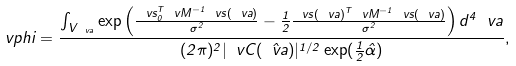Convert formula to latex. <formula><loc_0><loc_0><loc_500><loc_500>\ v p h i = \frac { \int _ { V _ { \ v a } } \exp \left ( \frac { \ v s ^ { T } _ { 0 } \ v M ^ { - 1 } \ v s ( \ v a ) } { \sigma ^ { 2 } } - \frac { 1 } { 2 } \frac { \ v s ( \ v a ) ^ { T } \ v M ^ { - 1 } \ v s ( \ v a ) } { \sigma ^ { 2 } } \right ) d ^ { 4 } \ v a } { ( 2 \pi ) ^ { 2 } | \ v C ( \hat { \ v a } ) | ^ { 1 / 2 } \exp ( \frac { 1 } { 2 } \hat { \alpha } ) } ,</formula> 